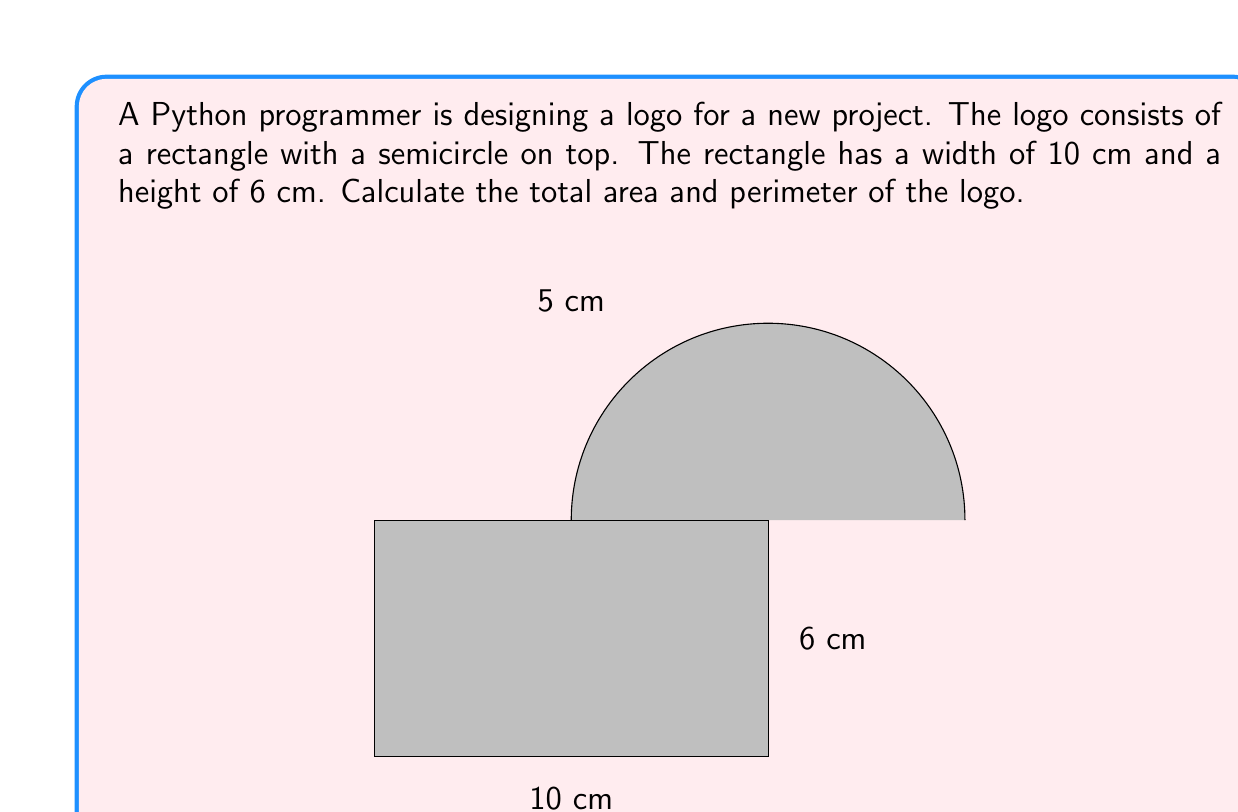What is the answer to this math problem? Let's break this problem down into steps:

1. Calculate the area of the rectangle:
   $A_{rectangle} = width \times height = 10 \text{ cm} \times 6 \text{ cm} = 60 \text{ cm}^2$

2. Calculate the area of the semicircle:
   The radius of the semicircle is half the width of the rectangle: $5 \text{ cm}$
   $A_{semicircle} = \frac{1}{2} \times \pi r^2 = \frac{1}{2} \times \pi \times 5^2 \text{ cm}^2 = \frac{25\pi}{2} \text{ cm}^2$

3. Total area:
   $A_{total} = A_{rectangle} + A_{semicircle} = 60 + \frac{25\pi}{2} \text{ cm}^2$

4. Calculate the perimeter:
   - Bottom of rectangle: $10 \text{ cm}$
   - Two sides of rectangle: $2 \times 6 \text{ cm} = 12 \text{ cm}$
   - Semicircle (half of full circle circumference): $\frac{1}{2} \times 2\pi r = \pi r = \pi \times 5 \text{ cm} = 5\pi \text{ cm}$

   $P_{total} = 10 + 12 + 5\pi \text{ cm} = 22 + 5\pi \text{ cm}$
Answer: Total Area: $$(60 + \frac{25\pi}{2}) \text{ cm}^2$$
Total Perimeter: $$(22 + 5\pi) \text{ cm}$$ 